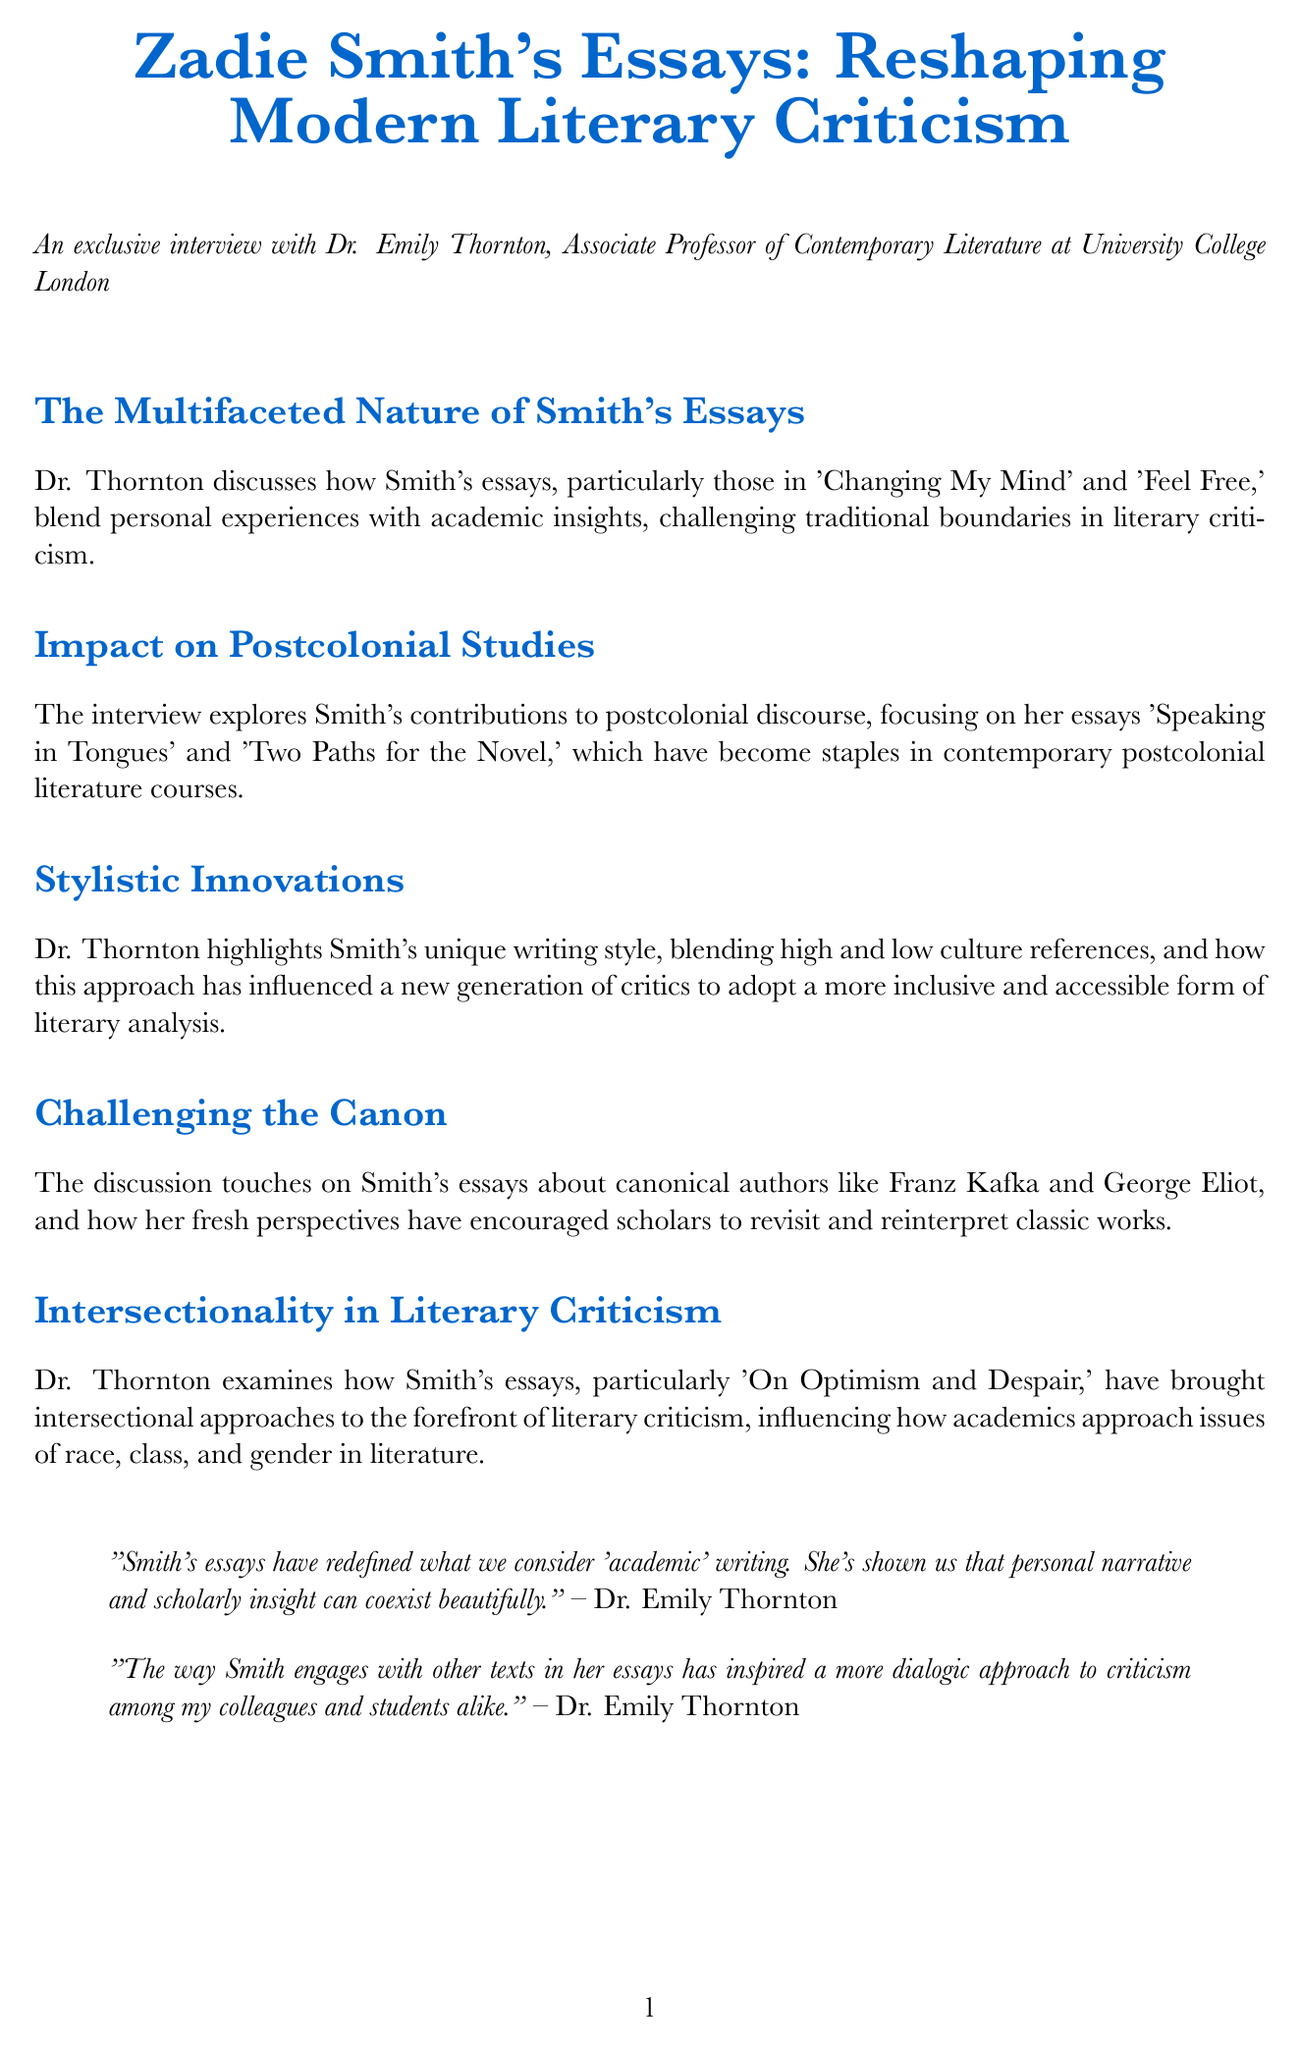What is the title of the newsletter? The title of the newsletter is explicitly stated at the beginning of the document.
Answer: Zadie Smith's Essays: Reshaping Modern Literary Criticism Who is the interviewee in the document? The interviewee's name and position are provided in the introduction section.
Answer: Dr. Emily Thornton What is the focus of Smith's essays discussed in "Impact on Postcolonial Studies"? This section outlines specific essays by Smith and their significance in a particular field, indicating their content.
Answer: Speaking in Tongues and Two Paths for the Novel What is the unique aspect of Smith's writing style mentioned? The document highlights an important characteristic of Smith's essays that impacts literary criticism.
Answer: Blending high and low culture references On what date is the virtual symposium about Zadie Smith scheduled? The specific dates for the upcoming event are detailed in the events section of the document.
Answer: October 15-17, 2023 Which term is used in the document to describe the engagement with other texts in Smith's essays? The interviewee comments on a specific approach to criticism in relation to Smith's work.
Answer: Dialogic approach What is a key theme explored in 'On Optimism and Despair'? The document summarizes the particular focus of this essay concerning literary criticism.
Answer: Intersectional approaches Who is the organizer of the upcoming event mentioned in the document? The document lists the entity responsible for organizing the virtual symposium.
Answer: Modern Language Association What type of academic position does Dr. Emily Thornton hold? The document specifies the exact title of the interviewee's role within their institution.
Answer: Associate Professor of Contemporary Literature 